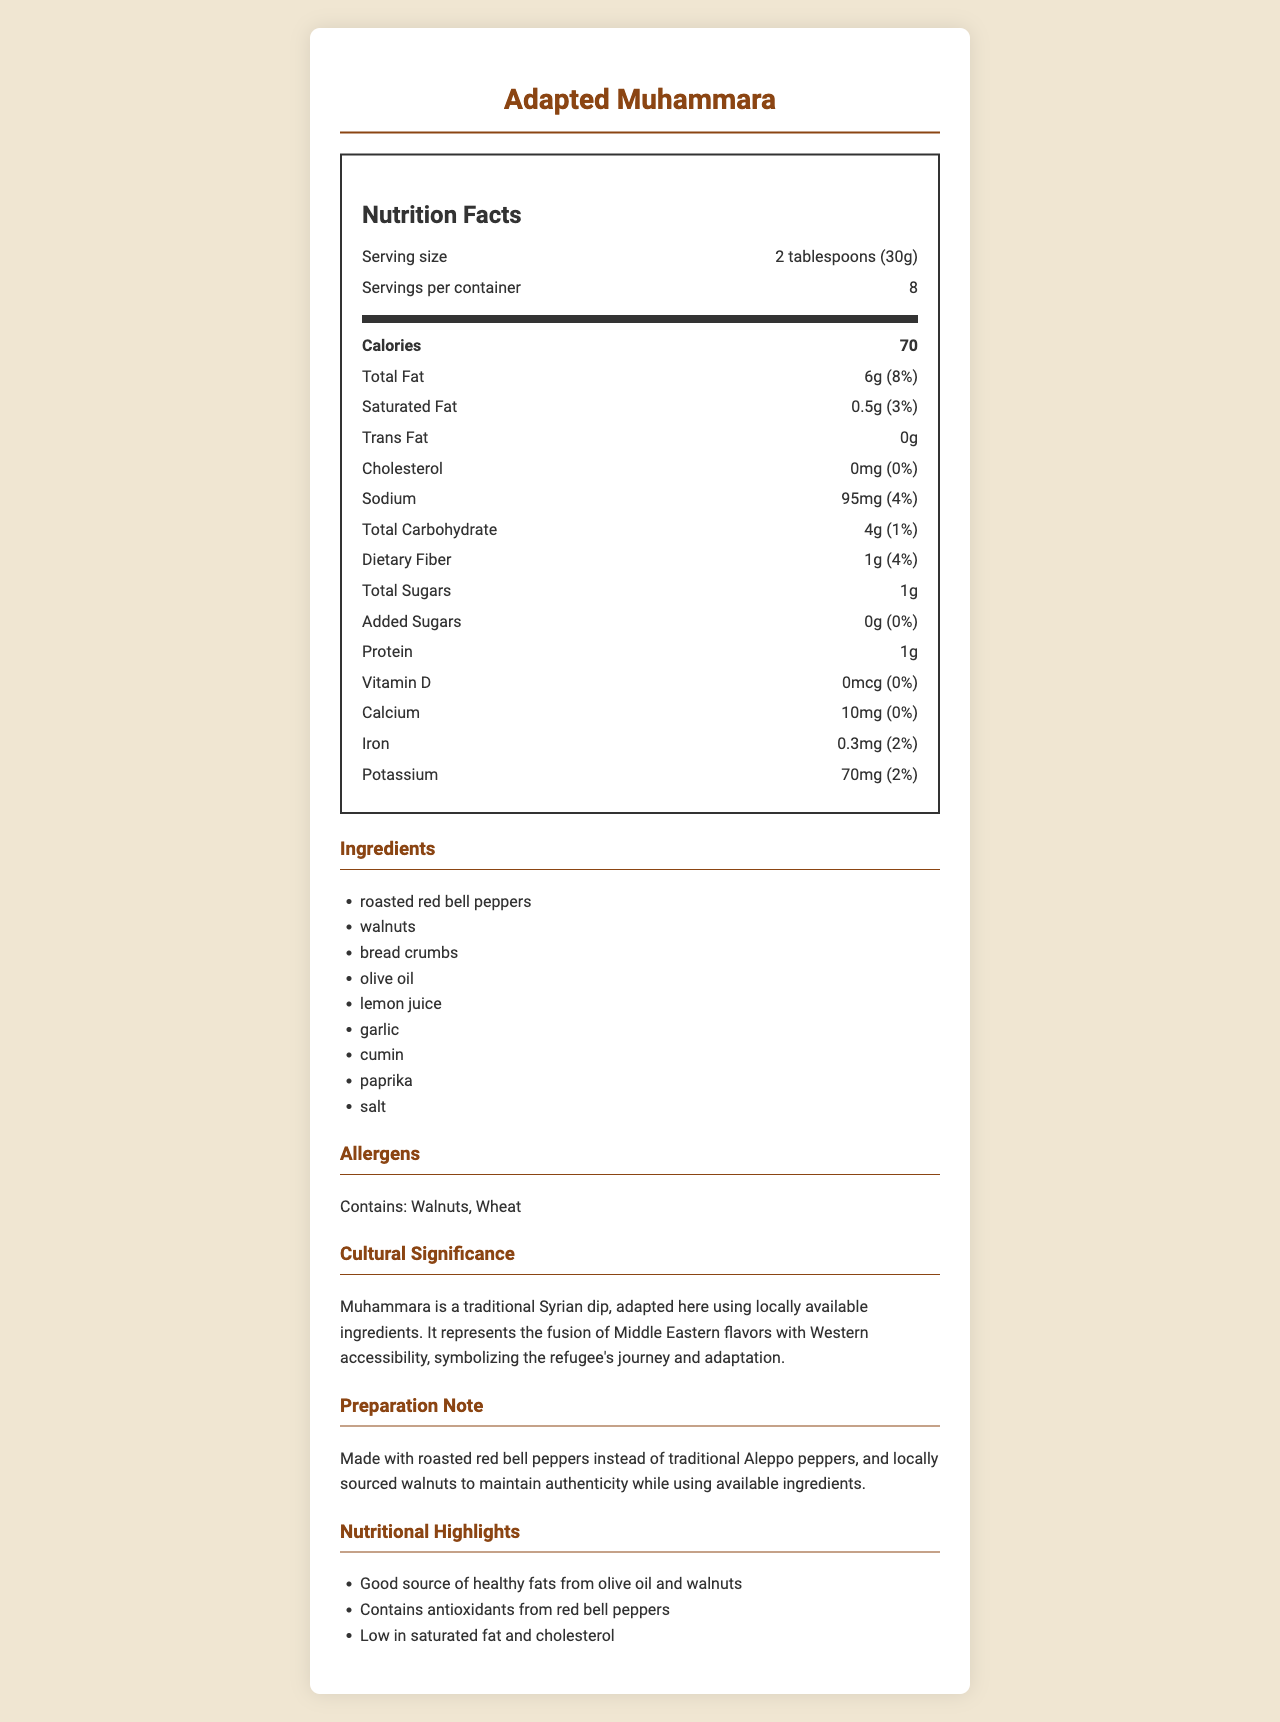what is the serving size of the dish "Adapted Muhammara"? The serving size is clearly mentioned under the Nutrition Facts section as "2 tablespoons (30g)".
Answer: 2 tablespoons (30g) how many calories are there per serving? The calories per serving are listed as "70" right under the serving size information.
Answer: 70 what is the daily value percentage of total fat? The daily value percentage of total fat is mentioned as "8%" next to the total fat amount.
Answer: 8% what ingredients in the dish could cause allergic reactions? The allergens section lists "Contains: Walnuts, Wheat", which are ingredients that could cause allergic reactions.
Answer: Walnuts, Wheat how much protein is in each serving? The amount of protein per serving is specified as "1g" in the Nutrition Facts section.
Answer: 1g which vitamins and minerals are present in the dish? A. Vitamin D and Iron B. Calcium and Potassium C. All of the above The dish contains Vitamin D (0mcg), Calcium (10mg), Iron (0.3mg), and Potassium (70mg).
Answer: C what is the amount of added sugars in each serving (in grams)? A. 0g B. 0.5g C. 1g D. 1.5g The amount of added sugars is listed as "0g" in the Nutrition Facts section.
Answer: A is the Adapted Muhammara low in cholesterol? The cholesterol amount is 0mg, which means it is low in cholesterol.
Answer: Yes summarize the main information provided in the document. The document gives comprehensive nutritional information about "Adapted Muhammara", ingredients used, allergens, cultural context, and highlights the health benefits such as healthy fats and low cholesterol content.
Answer: The document provides a detailed Nutrition Facts Label for a dish called "Adapted Muhammara", including serving size, number of servings, calorie content, and amounts of various nutrients. It also lists ingredients, allergens, and cultural significance, noting the adaptation using locally available ingredients while maintaining the dish's authenticity. Nutritional highlights emphasize the health benefits of the dish. how much saturated fat is contained in one serving? The amount of saturated fat in one serving is listed as "0.5g" under the Nutrition Facts.
Answer: 0.5g how many milligrams of sodium does one serving of Adapted Muhammara contain? The sodium content per serving is indicated as "95mg" in the Nutrition Facts section.
Answer: 95mg what percentage of the daily value of dietary fiber does one serving provide? The daily value percentage of dietary fiber is provided as "4%" next to the dietary fiber amount.
Answer: 4% what are the main ingredients used in the adaptation of the Muhammara dish? The ingredients are listed under the Ingredients section in the document.
Answer: Roasted red bell peppers, walnuts, bread crumbs, olive oil, lemon juice, garlic, cumin, paprika, salt could the traditional Aleppo peppers be sourced locally in the host country for this dish? The document mentions that roasted red bell peppers were used instead of traditional Aleppo peppers, but it doesn't provide information about whether Aleppo peppers are available locally in the host country.
Answer: Not enough information 